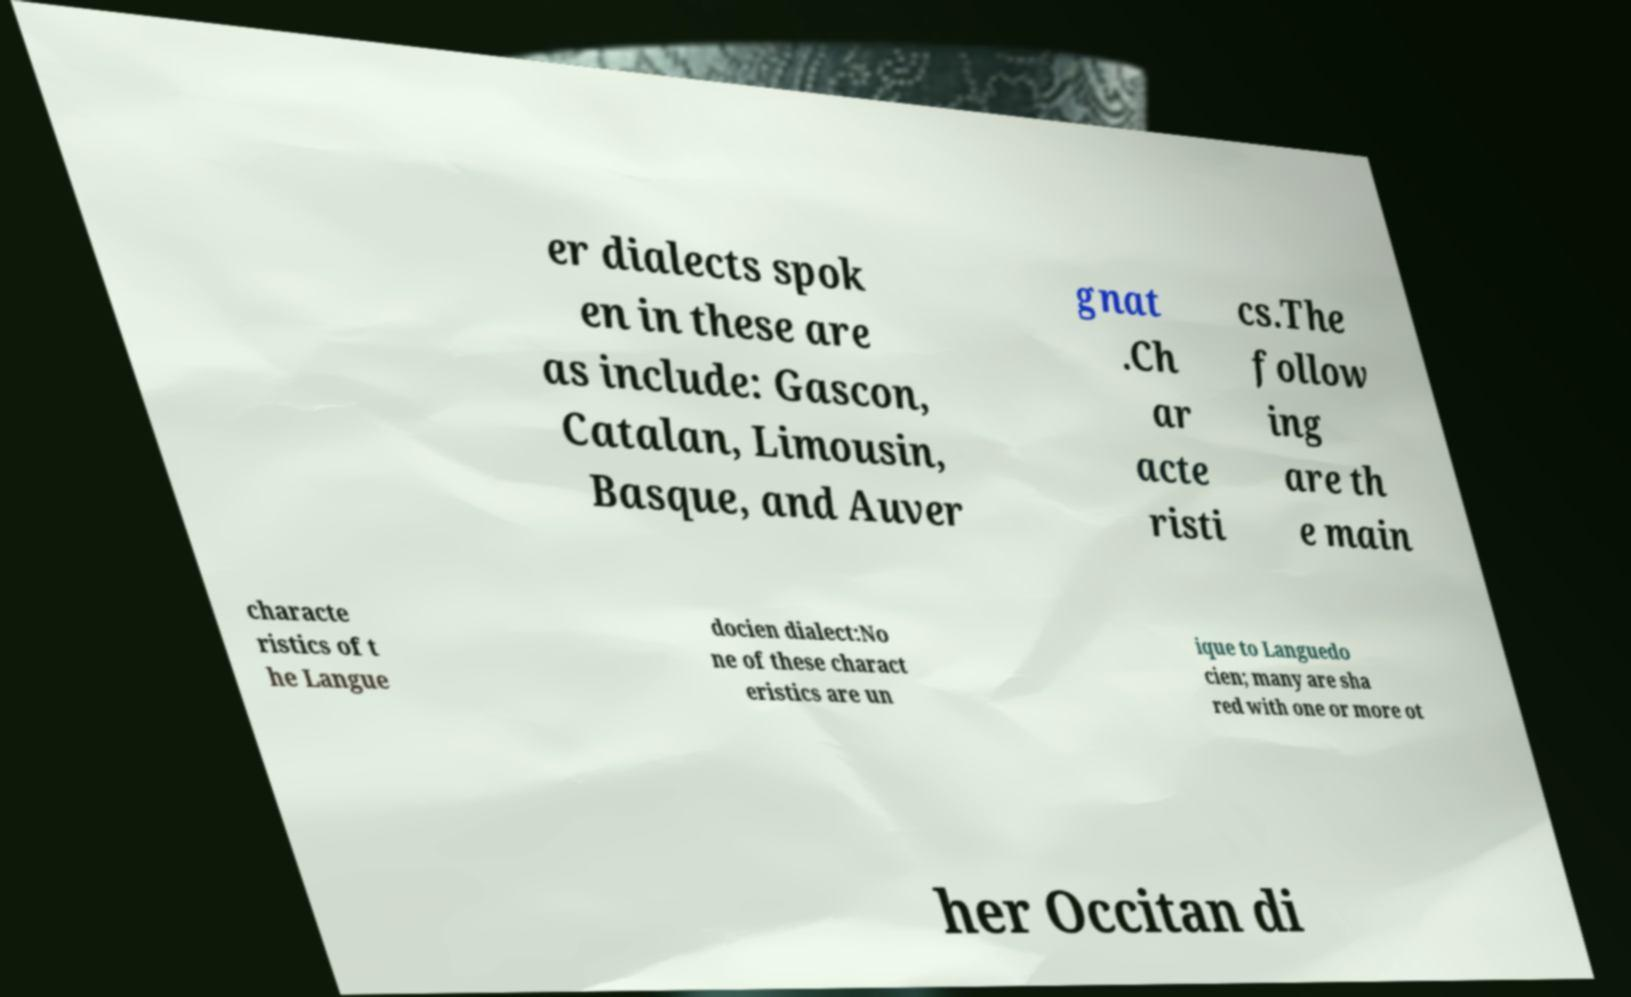Can you accurately transcribe the text from the provided image for me? er dialects spok en in these are as include: Gascon, Catalan, Limousin, Basque, and Auver gnat .Ch ar acte risti cs.The follow ing are th e main characte ristics of t he Langue docien dialect:No ne of these charact eristics are un ique to Languedo cien; many are sha red with one or more ot her Occitan di 